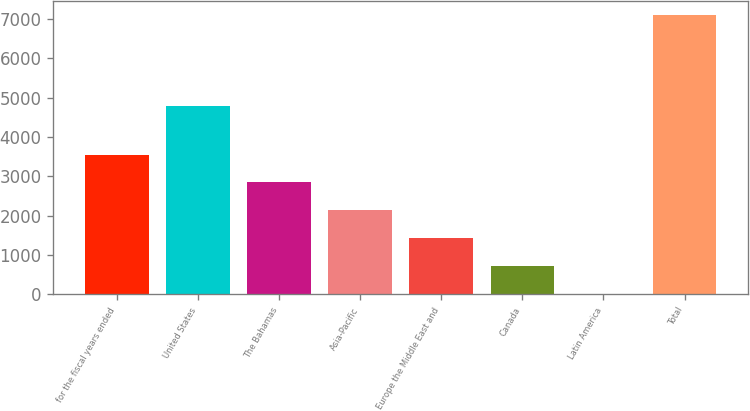Convert chart to OTSL. <chart><loc_0><loc_0><loc_500><loc_500><bar_chart><fcel>for the fiscal years ended<fcel>United States<fcel>The Bahamas<fcel>Asia-Pacific<fcel>Europe the Middle East and<fcel>Canada<fcel>Latin America<fcel>Total<nl><fcel>3555.3<fcel>4791.9<fcel>2846.16<fcel>2137.02<fcel>1427.88<fcel>718.74<fcel>9.6<fcel>7101<nl></chart> 